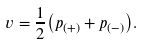<formula> <loc_0><loc_0><loc_500><loc_500>v = { \frac { 1 } { 2 } } { \left ( p _ { ( + ) } + p _ { ( - ) } \right ) } .</formula> 